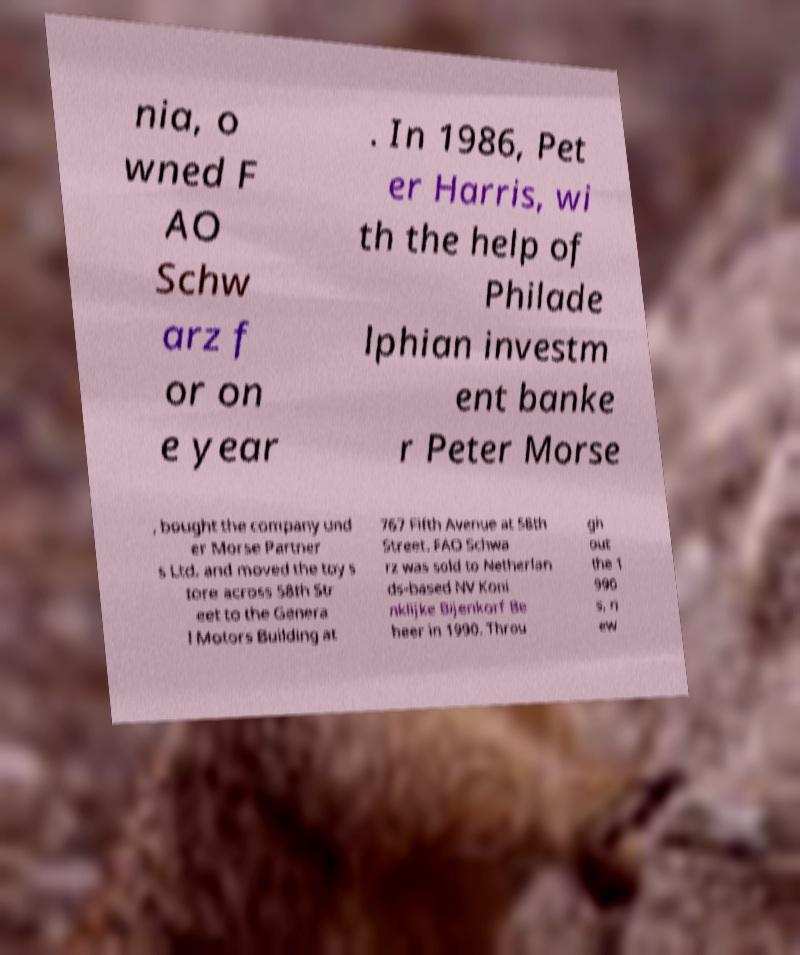Could you assist in decoding the text presented in this image and type it out clearly? nia, o wned F AO Schw arz f or on e year . In 1986, Pet er Harris, wi th the help of Philade lphian investm ent banke r Peter Morse , bought the company und er Morse Partner s Ltd. and moved the toy s tore across 58th Str eet to the Genera l Motors Building at 767 Fifth Avenue at 58th Street. FAO Schwa rz was sold to Netherlan ds-based NV Koni nklijke Bijenkorf Be heer in 1990. Throu gh out the 1 990 s, n ew 